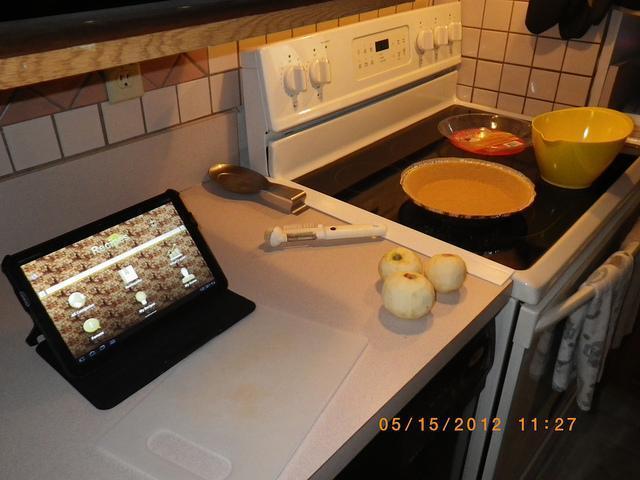How many pink candles?
Give a very brief answer. 0. How many parts are on top of the stove?
Give a very brief answer. 3. How many appliances are there?
Give a very brief answer. 1. How many bowls are there?
Give a very brief answer. 2. How many red bikes are there?
Give a very brief answer. 0. 